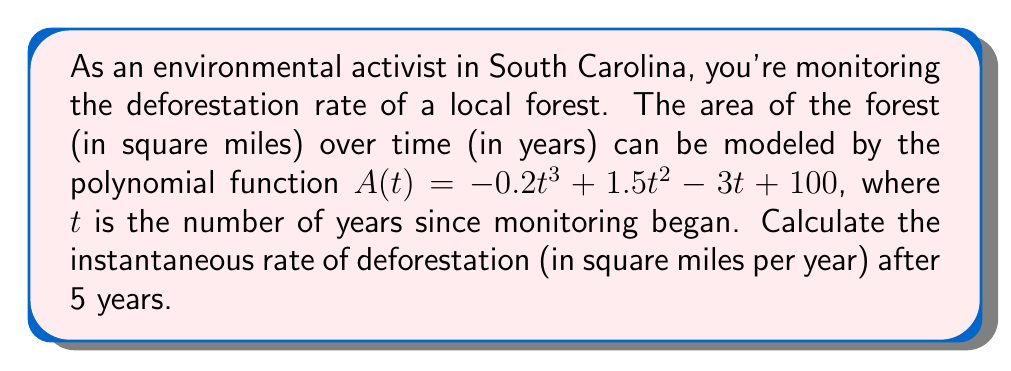Show me your answer to this math problem. To find the instantaneous rate of deforestation after 5 years, we need to follow these steps:

1) The rate of change of the forest area is given by the derivative of $A(t)$ with respect to $t$.

2) Let's find $A'(t)$ using the power rule:
   $$A'(t) = -0.6t^2 + 3t - 3$$

3) The negative of $A'(t)$ gives us the rate of deforestation:
   $$\text{Deforestation rate} = -A'(t) = 0.6t^2 - 3t + 3$$

4) We want to find the rate after 5 years, so we substitute $t = 5$:
   $$\text{Deforestation rate at } t = 5 = 0.6(5)^2 - 3(5) + 3$$

5) Let's calculate:
   $$0.6(25) - 15 + 3 = 15 - 15 + 3 = 3$$

Therefore, the instantaneous rate of deforestation after 5 years is 3 square miles per year.
Answer: 3 square miles per year 